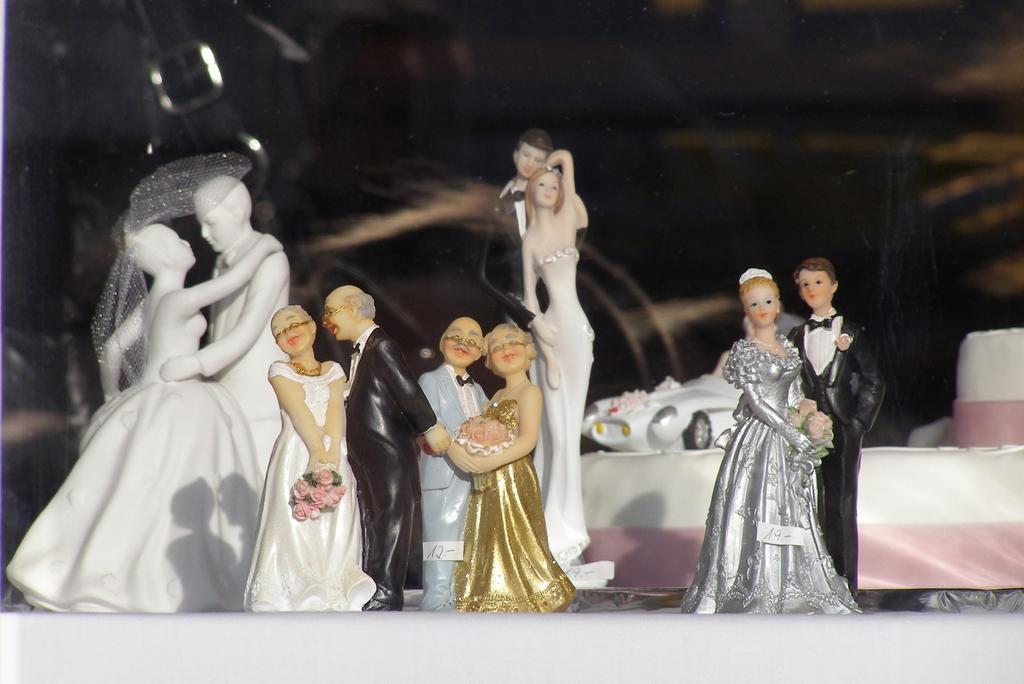In one or two sentences, can you explain what this image depicts? Here we can see five couple sculptures on a platform. In the background we can see a toy car and some other items. 